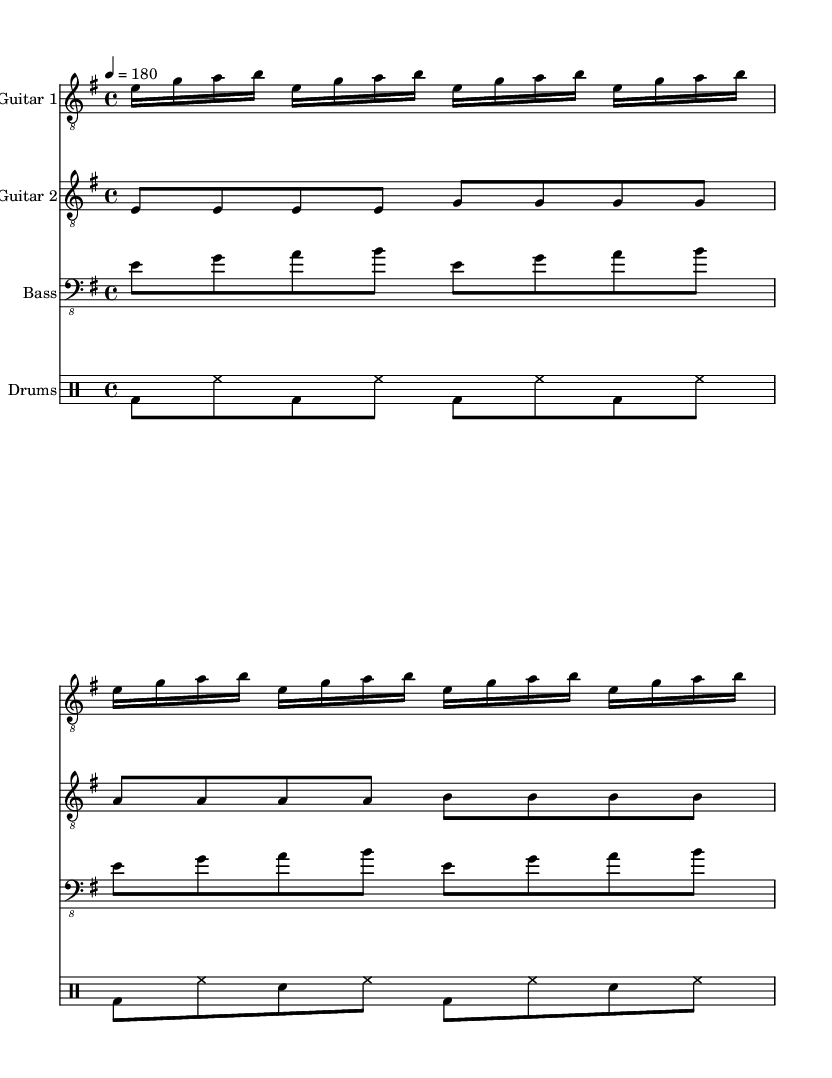What is the key signature of this music? The music is in E minor, indicated by the presence of one sharp (F#) in the key signature.
Answer: E minor What is the time signature of the piece? The time signature shown is 4/4, which means there are four beats in each measure, and the quarter note gets one beat.
Answer: 4/4 What is the tempo marking for this section? The tempo marking states "4 = 180," meaning the quarter note is to be played at a speed of 180 beats per minute.
Answer: 180 How many measures are in the part for Guitar 1? By counting the repeated sections, there are a total of 4 measures present for Guitar 1, as each of the repeated sections consists of 2 measures and this section is played twice.
Answer: 4 Which instrument has the clef marked as "bass_8"? The 'bass_8' clef is used for the bass guitar part, which indicates that the music is written for the bass staff, commonly used for lower-pitched instruments like the bass guitar.
Answer: Bass What type of rhythmic pattern is primarily used in the drum part? The drum part primarily features a steady eighth-note rhythm alternating between bass drum and hi-hat, creating a driving beat typical of thrash metal.
Answer: Eighth-note rhythm How many different instruments are included in this score? The score includes a total of four different instruments: Guitar 1, Guitar 2, Bass, and Drums.
Answer: Four 